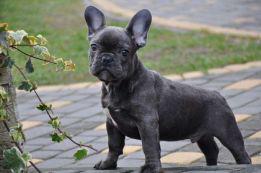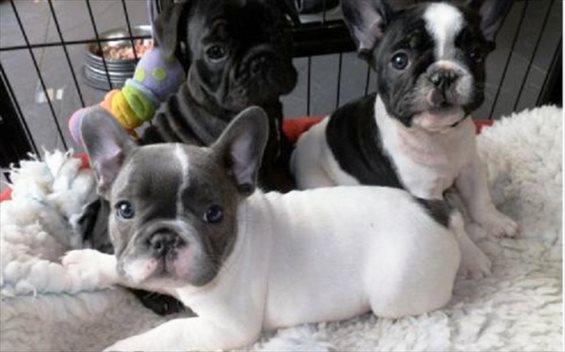The first image is the image on the left, the second image is the image on the right. Evaluate the accuracy of this statement regarding the images: "There are at most two dogs.". Is it true? Answer yes or no. No. The first image is the image on the left, the second image is the image on the right. Assess this claim about the two images: "Both dogs are standing on all four feet.". Correct or not? Answer yes or no. No. 